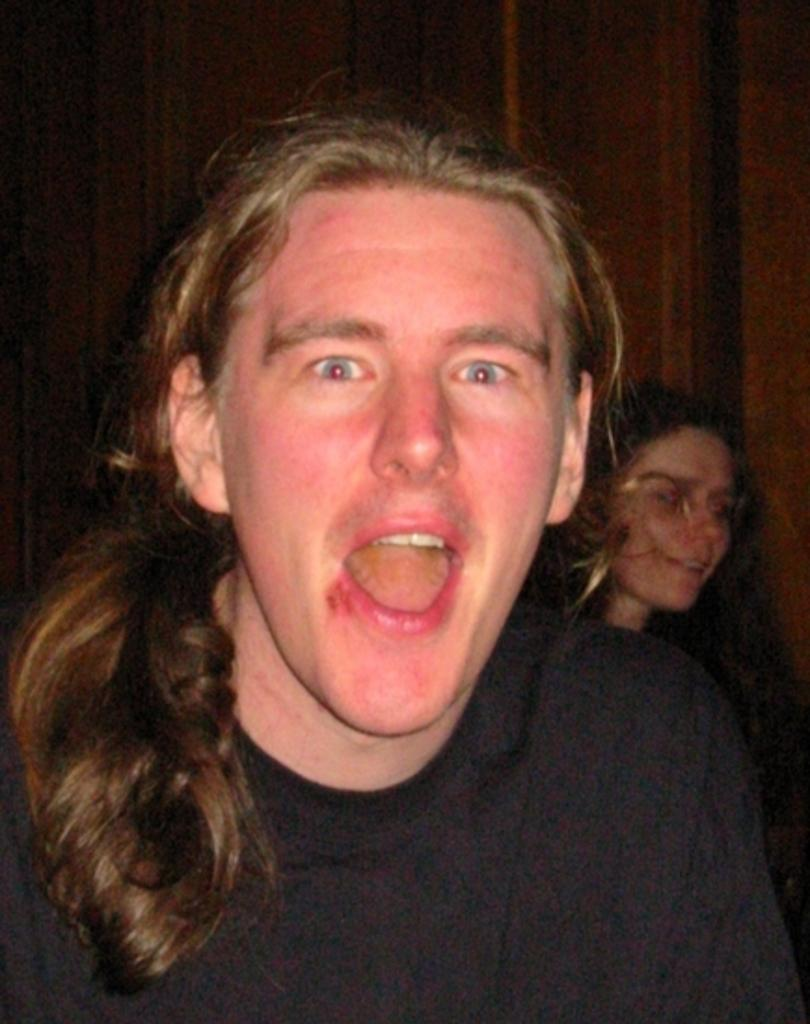Who is the main subject in the image? There is a man in the image. Can you describe the setting of the image? There is a wall visible in the background of the image. Are there any other people present in the image? Yes, there is a woman in the background of the image. What type of fish is the man holding in the image? There is no fish present in the image; the man is not holding anything. 